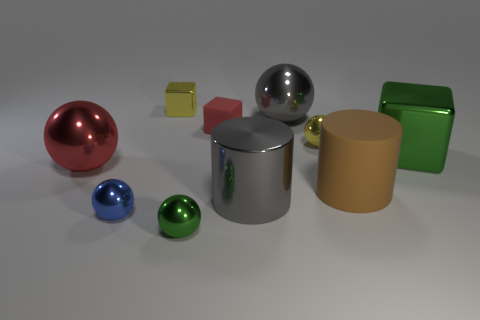Subtract all green spheres. How many spheres are left? 4 Subtract all cyan spheres. Subtract all red cylinders. How many spheres are left? 5 Subtract all blocks. How many objects are left? 7 Add 8 yellow things. How many yellow things are left? 10 Add 2 gray shiny blocks. How many gray shiny blocks exist? 2 Subtract 1 yellow spheres. How many objects are left? 9 Subtract all cyan cylinders. Subtract all red rubber blocks. How many objects are left? 9 